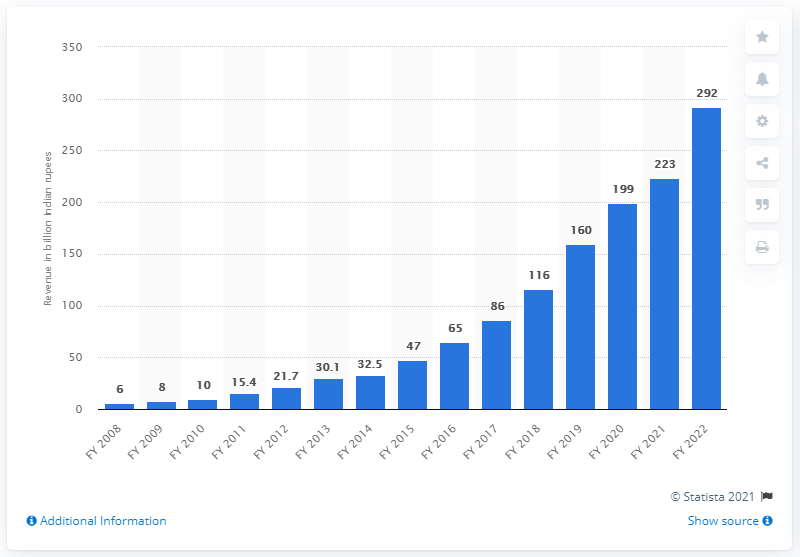List a handful of essential elements in this visual. Digital advertising in India in the financial year 2020 was valued at approximately 199... 